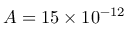<formula> <loc_0><loc_0><loc_500><loc_500>A = 1 5 \times 1 0 ^ { - 1 2 }</formula> 